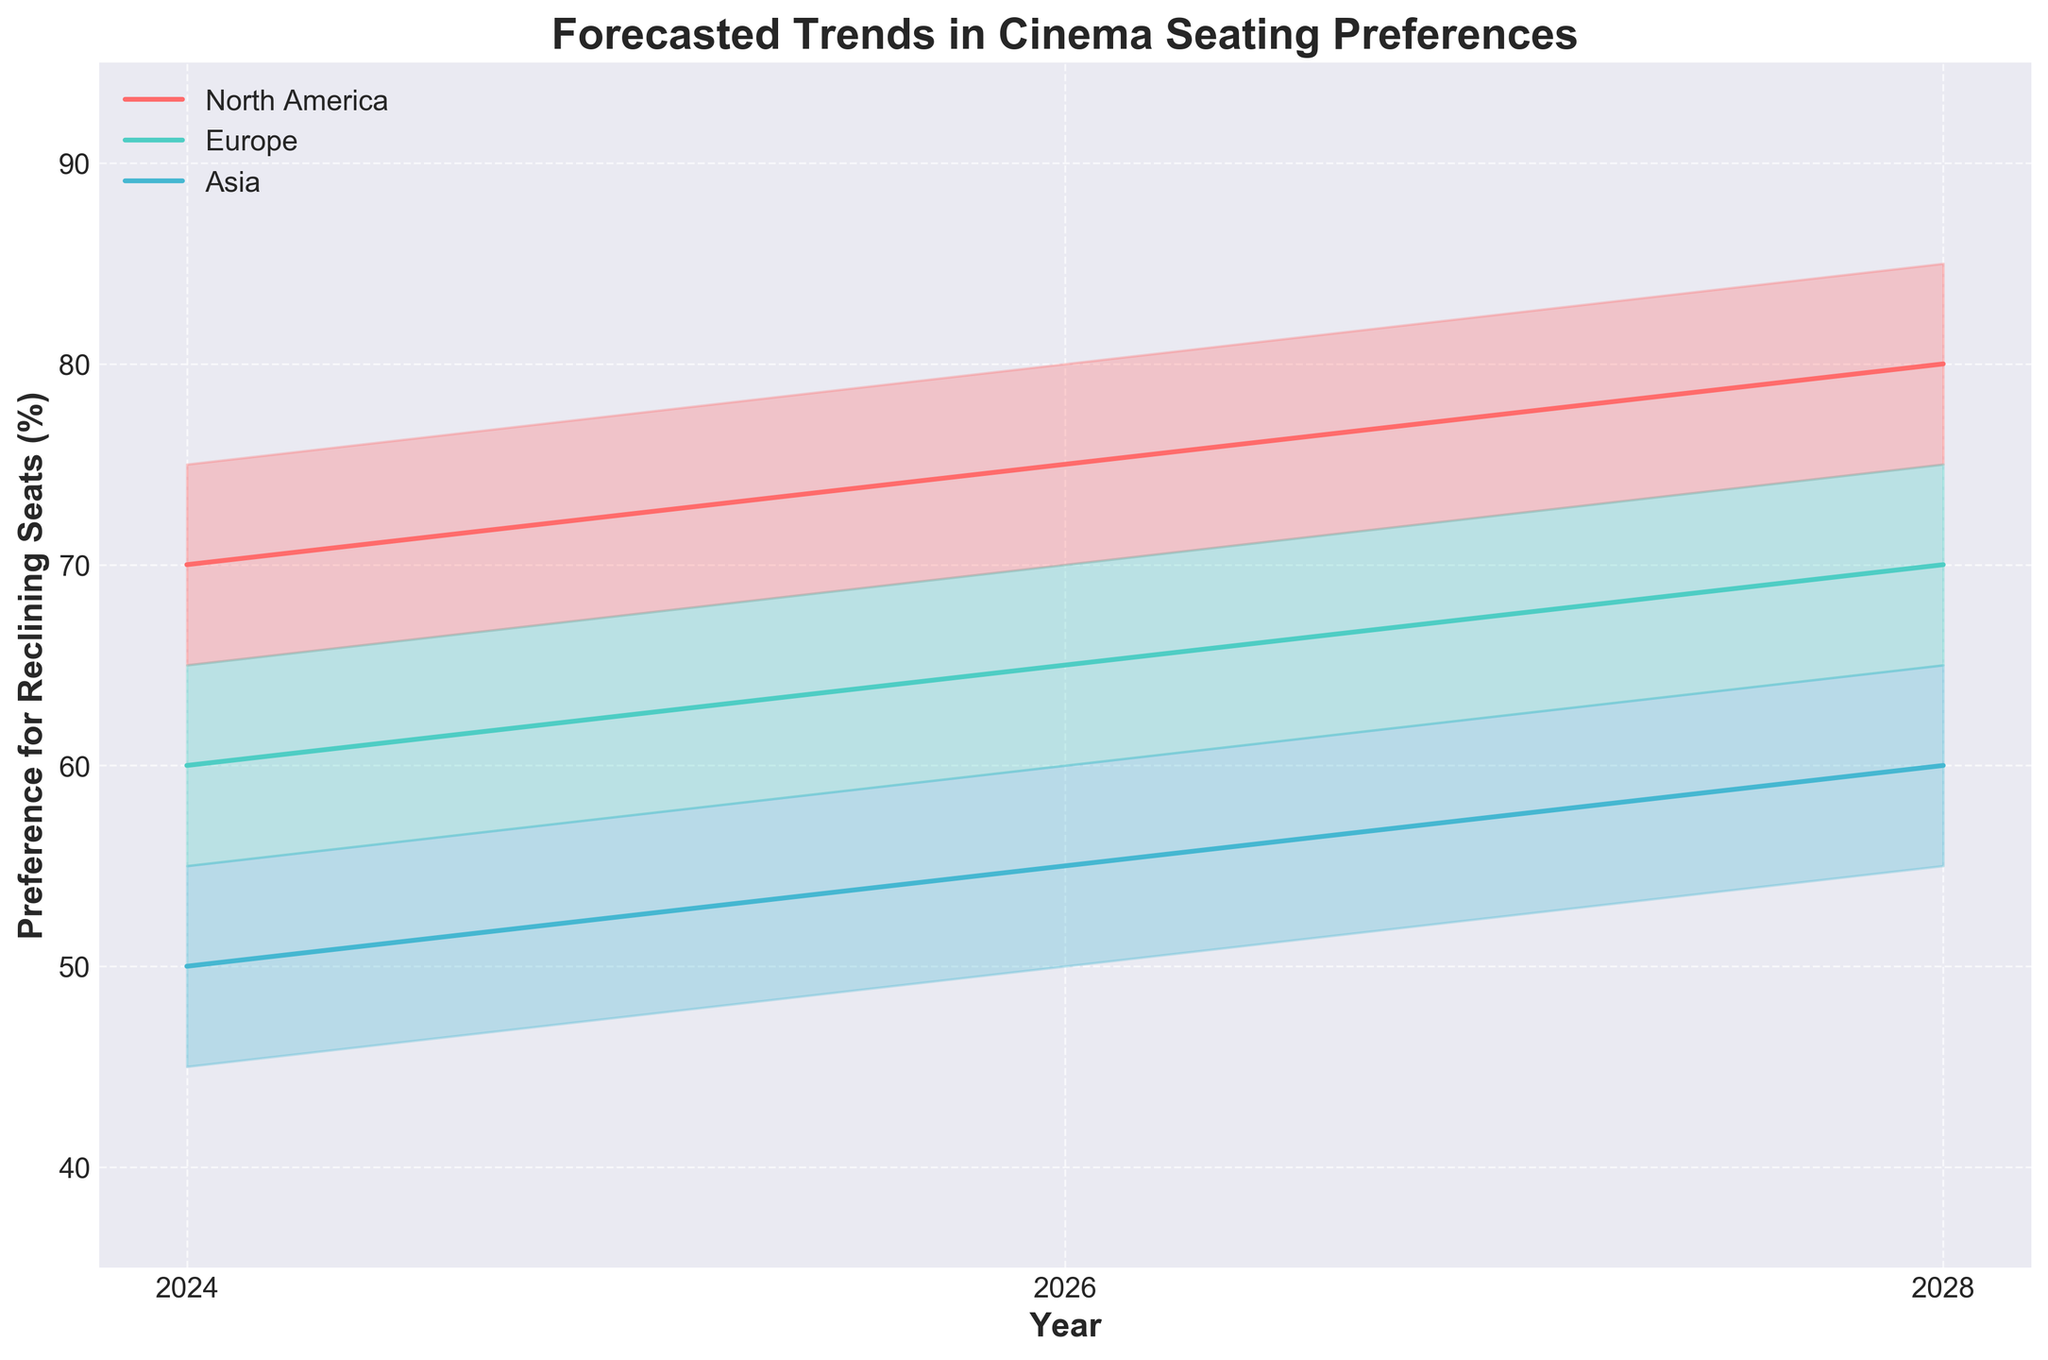What is the title of the figure? The title of the figure is usually prominently displayed at the top. It provides an immediate understanding of what the figure represents.
Answer: Forecasted Trends in Cinema Seating Preferences What is the forecasted median preference for reclining seats in North America for the 31-50 age group in 2026? To determine this, look for the median value on the plot corresponding to the 31-50 age group in North America for the year 2026. The median value indicates the central preference.
Answer: 80% How does the forecasted upper bound preference for reclining seats in Asia change from 2024 to 2028 for the 51+ age group? Identify the upper bound values for the 51+ age group in Asia for both 2024 and 2028. Compare these values to see the change (increase or decrease).
Answer: It increases from 50% to 60% Which region shows the highest median preference for reclining seats in 2028, and what is the value? Find the median preference values for each region in 2028. Identify the highest value and the corresponding region.
Answer: North America, 85% How does the trend of median preferences for reclining seats differ between Europe and Asia in 2026 for the 18-30 age group? Compare the median preference values for both Europe and Asia in 2026 for the 18-30 age group to see the difference. Calculate the numerical difference if needed.
Answer: Europe has a higher median preference (65%) compared to Asia (55%) What is the average forecasted lower bound preference for reclining seats across all regions in 2024? To find this, sum the lower bound values of all regions for 2024 and divide by the total number of regions. This gives the average lower bound preference. (65 + 60 + 50 + 55 + 60 + 50 + 45 + 50 + 40) / 9
Answer: 52.8% Is the forecasted median preference for reclining seats consistently increasing, decreasing, or fluctuating in North America from 2024 to 2028? Evaluate the median preference values for North America across the years (2024, 2026, 2028) and determine the pattern: increasing, decreasing, or fluctuating.
Answer: Increasing What is the forecasted range (difference between upper and lower bounds) of preference for reclining seats in Europe for the 51+ age group in 2028? Calculate the range by subtracting the lower bound from the upper bound for Europe in the 51+ age group for the year 2028. (70 - 60)
Answer: 10% Compare the median preference growth for reclining seats from 2024 to 2028 between the 18-30 age group in North America and Europe. Determine the median preference growth by subtracting the 2024 value from the 2028 value for the 18-30 age group in both North America and Europe. Compare these growth values. (80-70) for NA and (70-60) for EU
Answer: North America: 10%, Europe: 10% What is the lowest forecasted median preference for reclining seats across all regions and age groups in 2028? Look at the median preference values for all regions and age groups in 2028 and identify the lowest value.
Answer: 55% in Asia for the 18-30 age group 